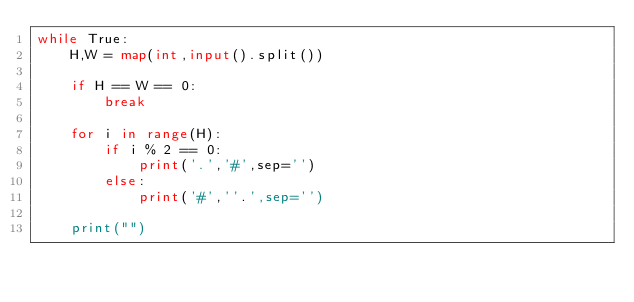Convert code to text. <code><loc_0><loc_0><loc_500><loc_500><_Python_>while True:
    H,W = map(int,input().split())

    if H == W == 0:
        break
    
    for i in range(H):
        if i % 2 == 0:
            print('.','#',sep='')
        else:
            print('#',''.',sep='')

    print("")
            
            
            
</code> 